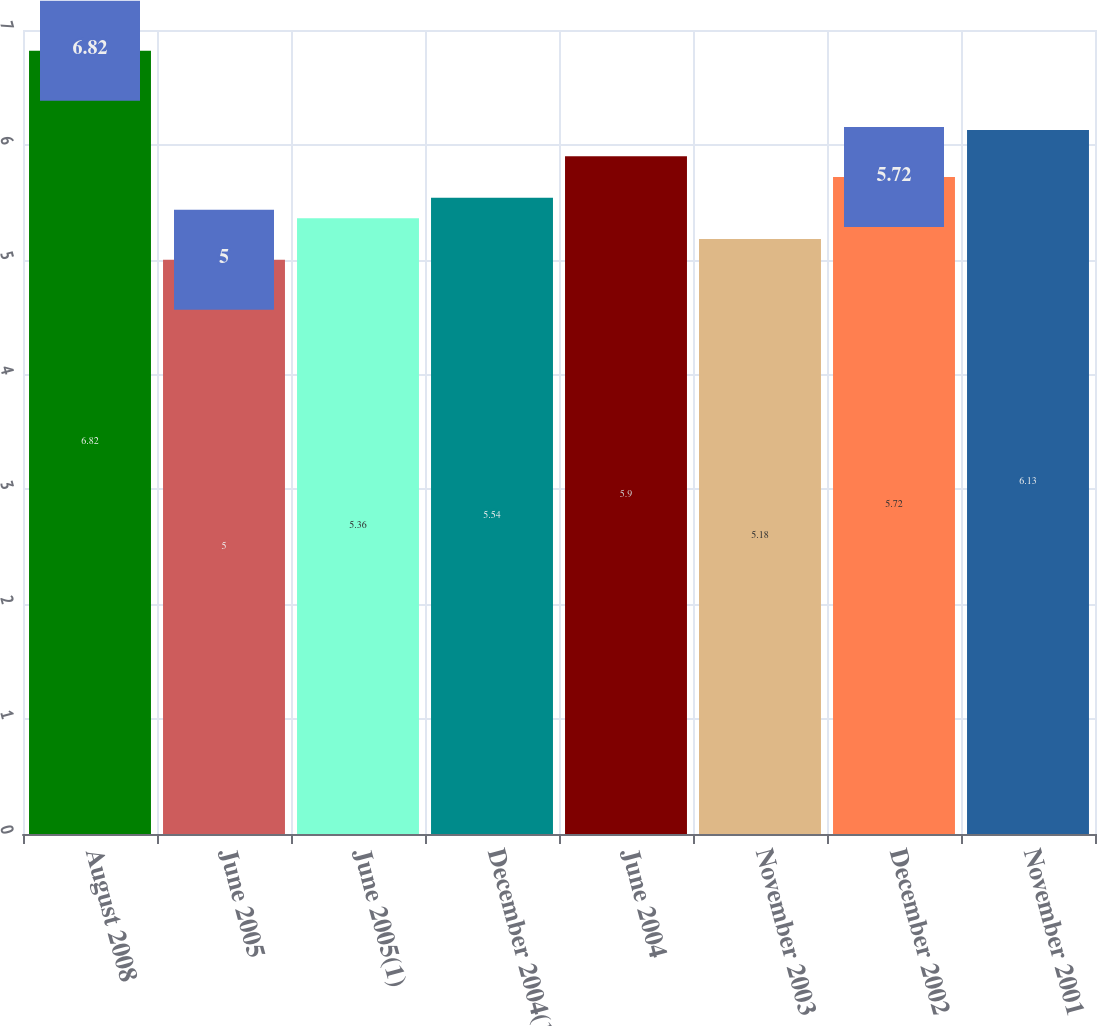Convert chart to OTSL. <chart><loc_0><loc_0><loc_500><loc_500><bar_chart><fcel>August 2008<fcel>June 2005<fcel>June 2005(1)<fcel>December 2004(1)<fcel>June 2004<fcel>November 2003<fcel>December 2002<fcel>November 2001<nl><fcel>6.82<fcel>5<fcel>5.36<fcel>5.54<fcel>5.9<fcel>5.18<fcel>5.72<fcel>6.13<nl></chart> 